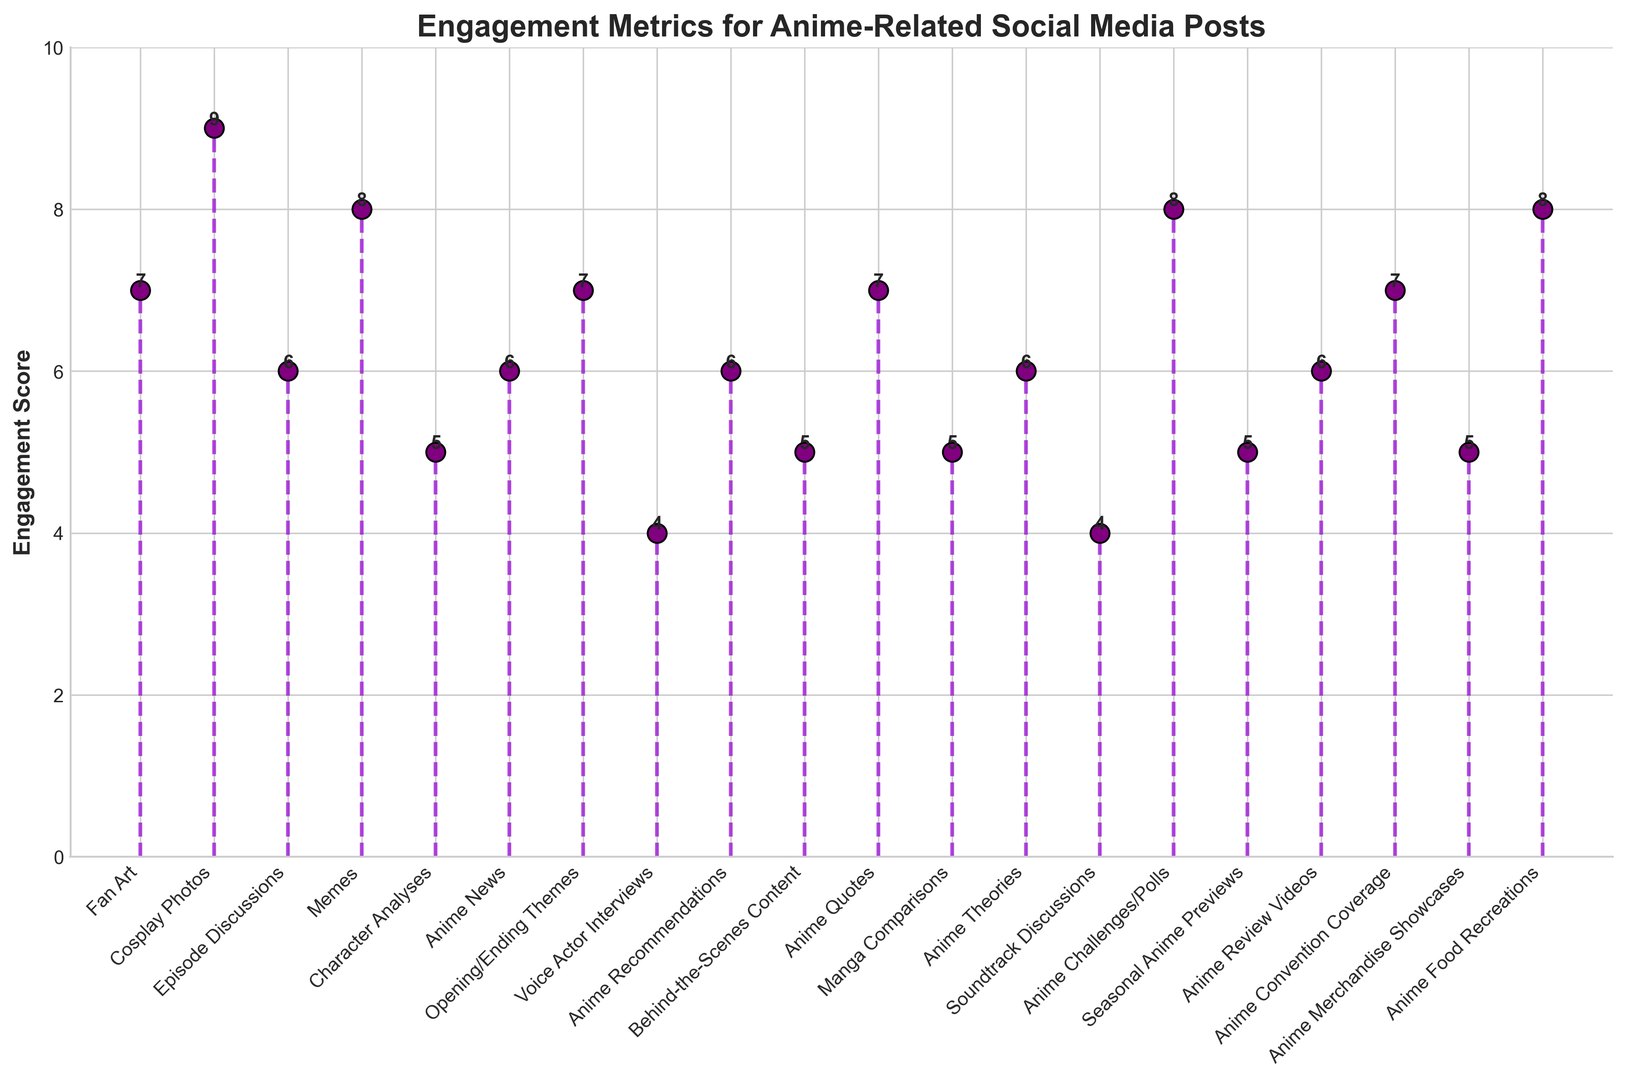What's the highest engagement score among the different types of anime-related posts? The highest engagement score is indicated by the tallest stem in the plot. By inspecting the plot, the highest stem corresponds to "Cosplay Photos," which has an engagement score of 9.
Answer: 9 What type of post has the lowest engagement score? The lowest engagement score is represented by the shortest stem in the plot. The shortest stems correspond to "Voice Actor Interviews" and "Soundtrack Discussions," both of which have an engagement score of 4.
Answer: Voice Actor Interviews, Soundtrack Discussions Which type of post has a higher engagement score, "Fan Art" or "Anime News"? By comparing the heights of the stems for "Fan Art" and "Anime News," it can be seen that "Fan Art" has a score of 7, while "Anime News" has a score of 6. Therefore, "Fan Art" has a higher engagement score.
Answer: Fan Art What is the average engagement score of all the posts? To find the average engagement score, sum up all the scores and divide by the number of types of posts. The scores are: 7, 9, 6, 8, 5, 6, 7, 4, 6, 5, 7, 5, 6, 4, 8, 5, 6, 7, 5, 8. The sum is 120, and there are 20 posts. The average is 120/20 = 6.
Answer: 6 Is the engagement score of "Anime Challenges/Polls" greater than "Memes"? By comparing the heights of the stems for "Anime Challenges/Polls" and "Memes," "Anime Challenges/Polls" has an engagement score of 8, while "Memes" also has a score of 8. Both have equal engagement scores.
Answer: No, they are equal What is the median engagement score among the types of posts? To find the median engagement score, first, list the scores in ascending order: 4, 4, 5, 5, 5, 5, 5, 6, 6, 6, 6, 6, 7, 7, 7, 7, 8, 8, 8, 9. With 20 scores, the median will be the average of the 10th and 11th values: (6+6)/2 = 6.
Answer: 6 What's the total engagement score for posts relating to discussions ("Episode Discussions" and "Soundtrack Discussions")? Sum the engagement scores of "Episode Discussions" and "Soundtrack Discussions." Episode Discussions has a score of 6 and Soundtrack Discussions has a score of 4. Therefore, 6 + 4 = 10.
Answer: 10 Among anime-related posts with an engagement score of 7, how many different types of posts are there? Count the number of stems with a height corresponding to an engagement score of 7. These posts are "Fan Art," "Opening/Ending Themes," "Anime Quotes," "Anime Convention Coverage," and "Anime Review Videos." There are 5 such types.
Answer: 5 Which engagement score is more common, 5 or 6? Count the number of stems with an engagement score of 5 and compare it to the number of stems with an engagement score of 6. There are 5 posts with a score of 5 and 6 posts with a score of 6. Therefore, a score of 6 is more common.
Answer: 6 